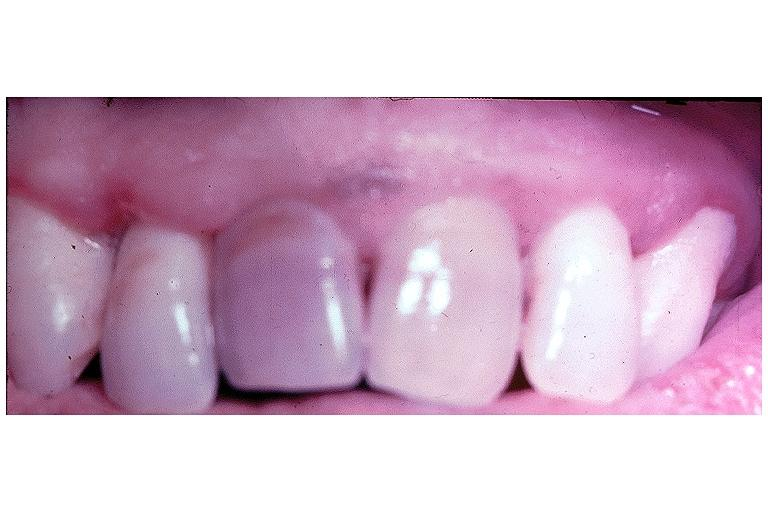does this image show pulpal necrosis?
Answer the question using a single word or phrase. Yes 